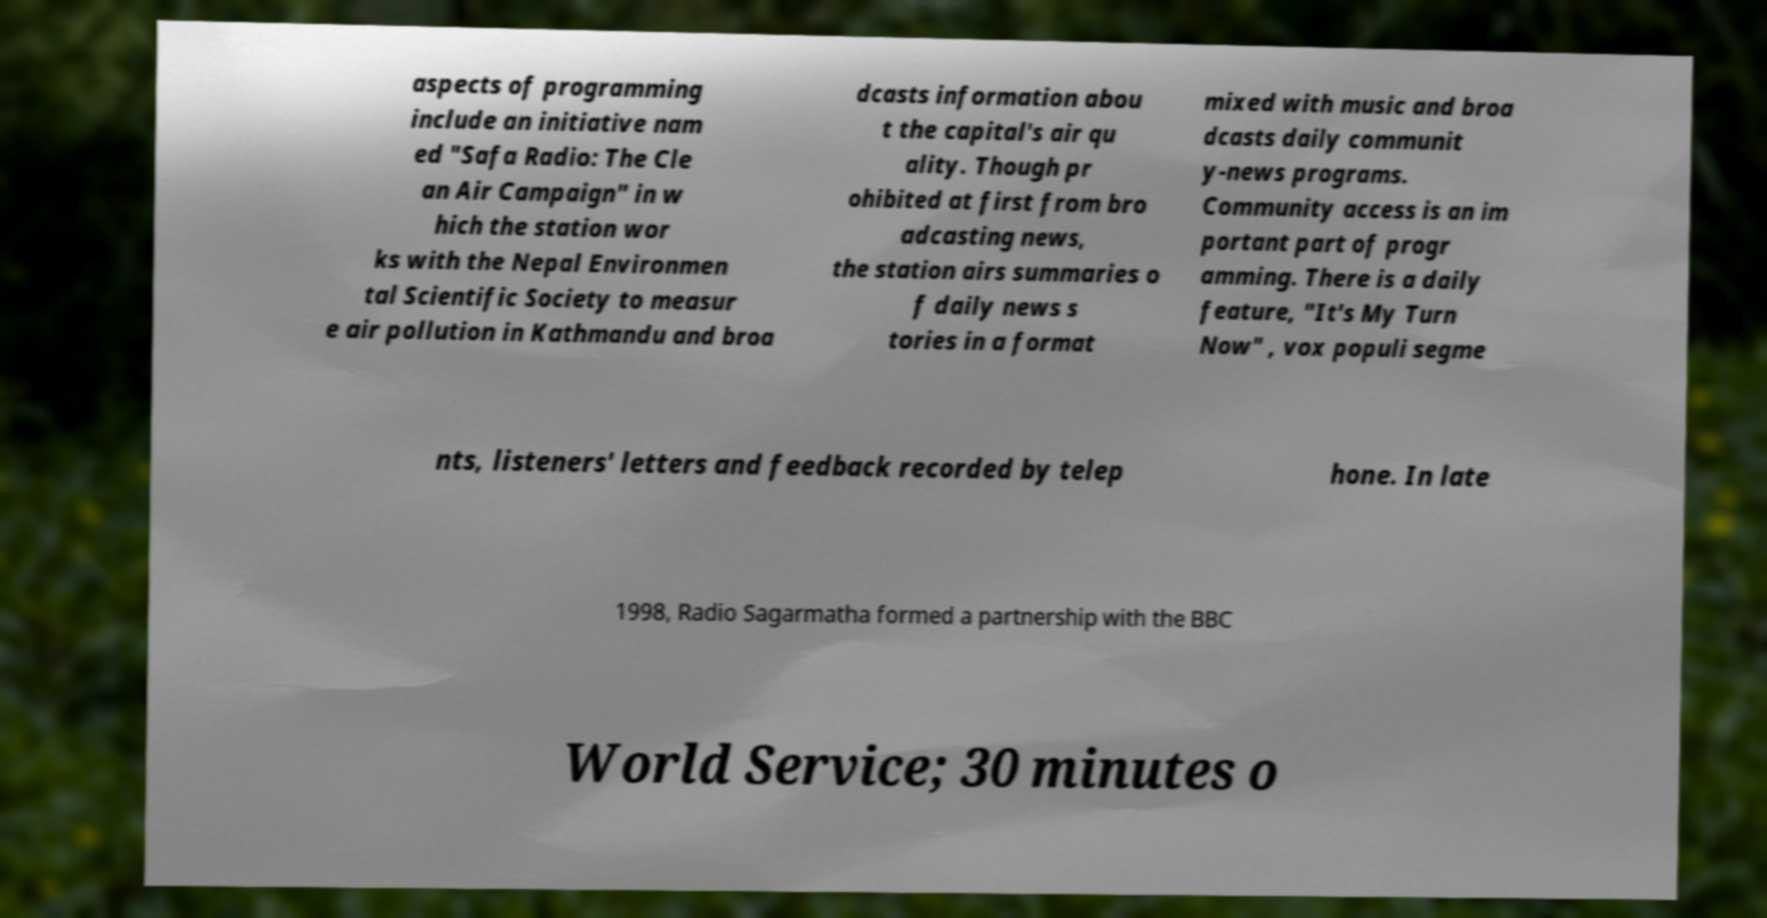Can you accurately transcribe the text from the provided image for me? aspects of programming include an initiative nam ed "Safa Radio: The Cle an Air Campaign" in w hich the station wor ks with the Nepal Environmen tal Scientific Society to measur e air pollution in Kathmandu and broa dcasts information abou t the capital's air qu ality. Though pr ohibited at first from bro adcasting news, the station airs summaries o f daily news s tories in a format mixed with music and broa dcasts daily communit y-news programs. Community access is an im portant part of progr amming. There is a daily feature, "It's My Turn Now" , vox populi segme nts, listeners' letters and feedback recorded by telep hone. In late 1998, Radio Sagarmatha formed a partnership with the BBC World Service; 30 minutes o 